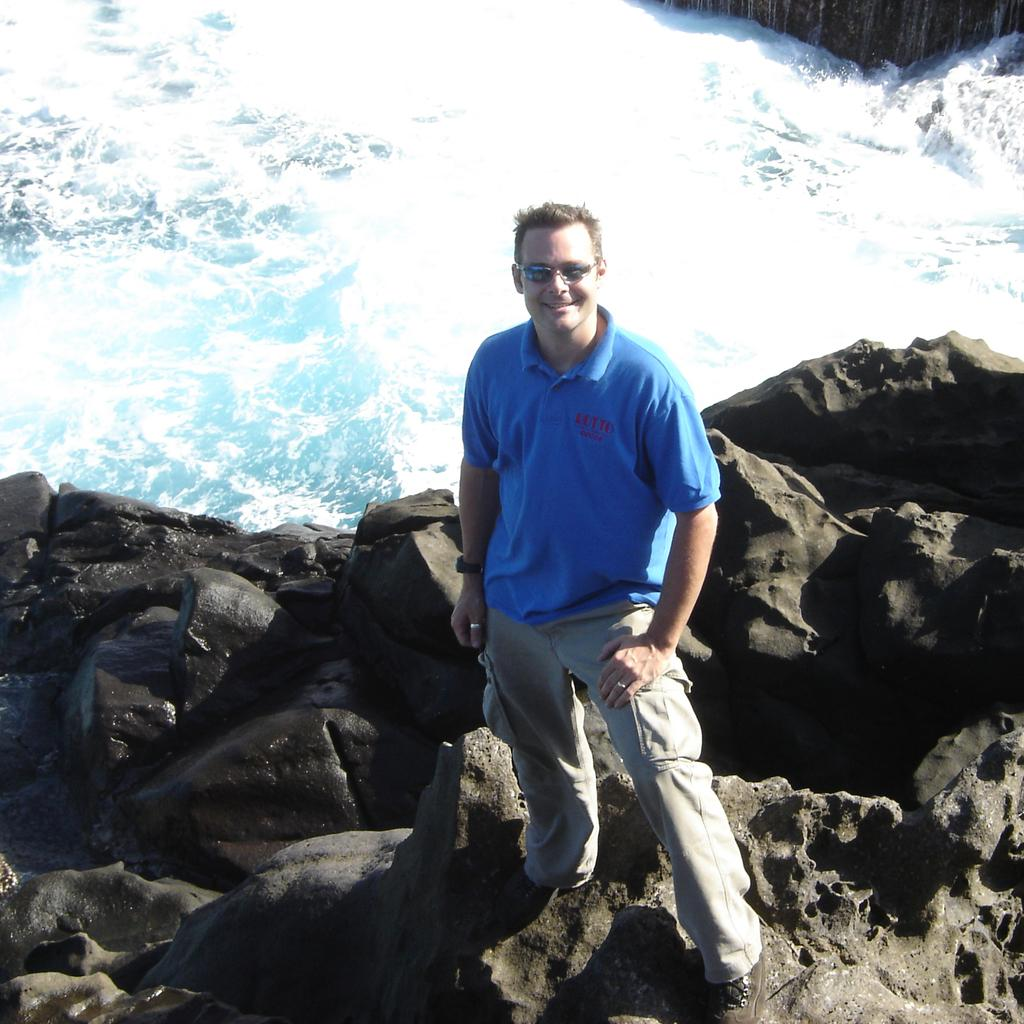Who or what is present in the image? There is a person in the image. What type of terrain is visible at the bottom of the image? There are rocks at the bottom of the image. What natural element is visible at the top of the image? There is water visible at the top of the image. What object can be seen at the top of the image? There is an object at the top of the image. How much was the payment for the sack in the image? There is no payment or sack present in the image. 